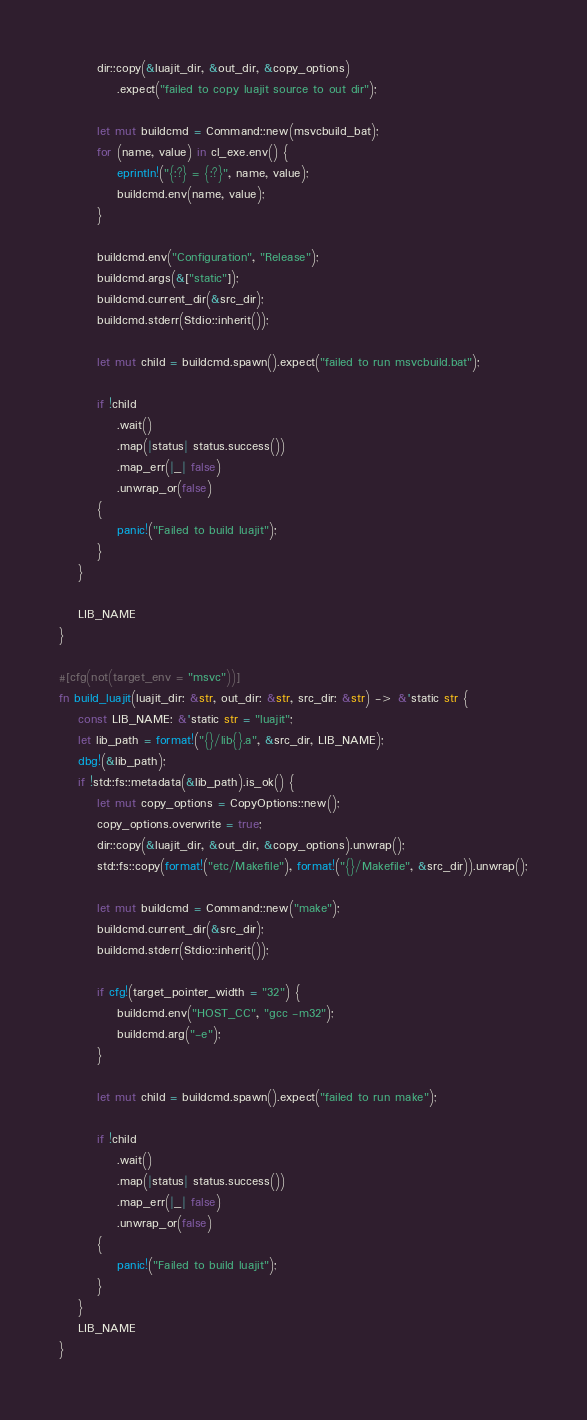Convert code to text. <code><loc_0><loc_0><loc_500><loc_500><_Rust_>        dir::copy(&luajit_dir, &out_dir, &copy_options)
            .expect("failed to copy luajit source to out dir");

        let mut buildcmd = Command::new(msvcbuild_bat);
        for (name, value) in cl_exe.env() {
            eprintln!("{:?} = {:?}", name, value);
            buildcmd.env(name, value);
        }

        buildcmd.env("Configuration", "Release");
        buildcmd.args(&["static"]);
        buildcmd.current_dir(&src_dir);
        buildcmd.stderr(Stdio::inherit());

        let mut child = buildcmd.spawn().expect("failed to run msvcbuild.bat");

        if !child
            .wait()
            .map(|status| status.success())
            .map_err(|_| false)
            .unwrap_or(false)
        {
            panic!("Failed to build luajit");
        }
    }

    LIB_NAME
}

#[cfg(not(target_env = "msvc"))]
fn build_luajit(luajit_dir: &str, out_dir: &str, src_dir: &str) -> &'static str {
    const LIB_NAME: &'static str = "luajit";
    let lib_path = format!("{}/lib{}.a", &src_dir, LIB_NAME);
    dbg!(&lib_path);
    if !std::fs::metadata(&lib_path).is_ok() {
        let mut copy_options = CopyOptions::new();
        copy_options.overwrite = true;
        dir::copy(&luajit_dir, &out_dir, &copy_options).unwrap();
        std::fs::copy(format!("etc/Makefile"), format!("{}/Makefile", &src_dir)).unwrap();

        let mut buildcmd = Command::new("make");
        buildcmd.current_dir(&src_dir);
        buildcmd.stderr(Stdio::inherit());

        if cfg!(target_pointer_width = "32") {
            buildcmd.env("HOST_CC", "gcc -m32");
            buildcmd.arg("-e");
        }

        let mut child = buildcmd.spawn().expect("failed to run make");

        if !child
            .wait()
            .map(|status| status.success())
            .map_err(|_| false)
            .unwrap_or(false)
        {
            panic!("Failed to build luajit");
        }
    }
    LIB_NAME
}
</code> 